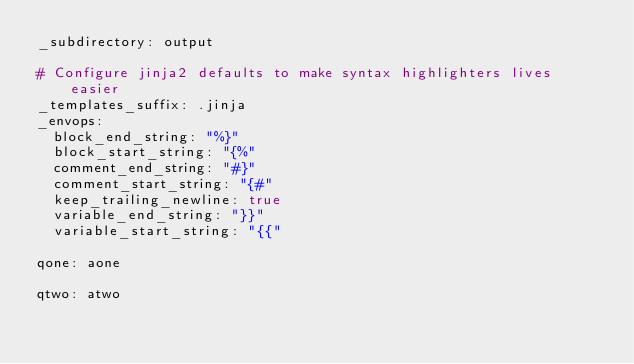<code> <loc_0><loc_0><loc_500><loc_500><_YAML_>_subdirectory: output

# Configure jinja2 defaults to make syntax highlighters lives easier
_templates_suffix: .jinja
_envops:
  block_end_string: "%}"
  block_start_string: "{%"
  comment_end_string: "#}"
  comment_start_string: "{#"
  keep_trailing_newline: true
  variable_end_string: "}}"
  variable_start_string: "{{"

qone: aone

qtwo: atwo</code> 